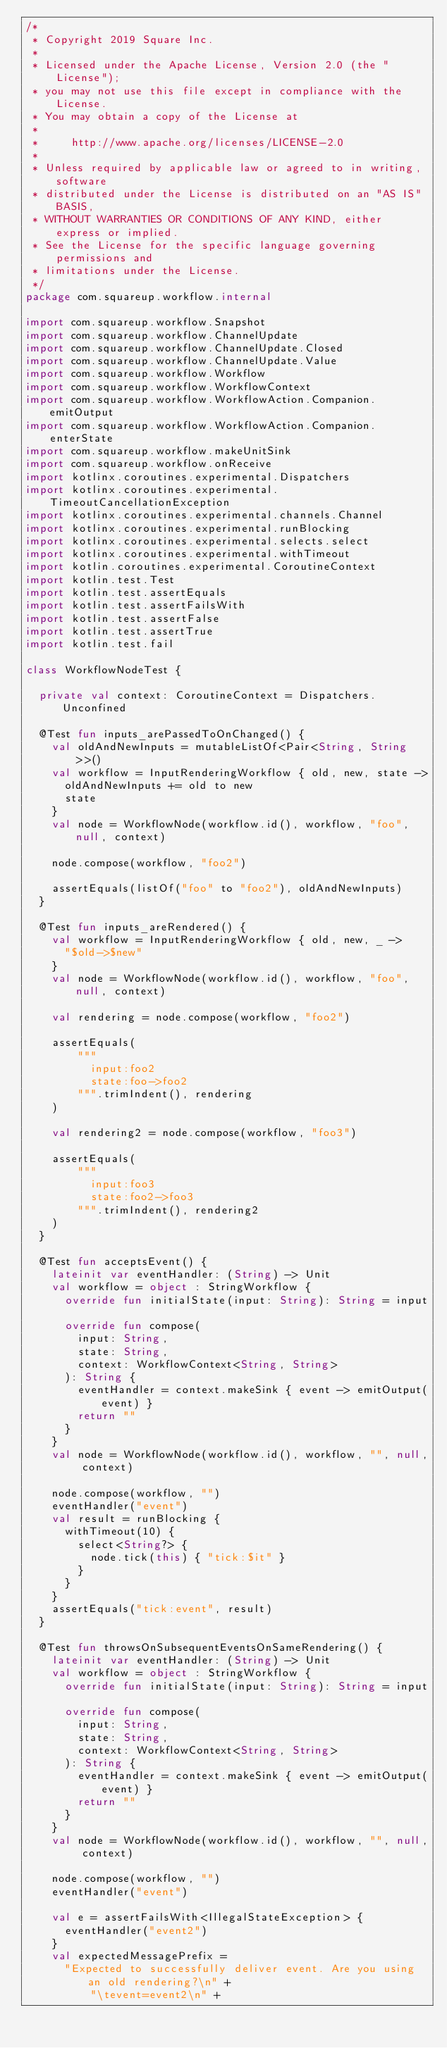Convert code to text. <code><loc_0><loc_0><loc_500><loc_500><_Kotlin_>/*
 * Copyright 2019 Square Inc.
 *
 * Licensed under the Apache License, Version 2.0 (the "License");
 * you may not use this file except in compliance with the License.
 * You may obtain a copy of the License at
 *
 *     http://www.apache.org/licenses/LICENSE-2.0
 *
 * Unless required by applicable law or agreed to in writing, software
 * distributed under the License is distributed on an "AS IS" BASIS,
 * WITHOUT WARRANTIES OR CONDITIONS OF ANY KIND, either express or implied.
 * See the License for the specific language governing permissions and
 * limitations under the License.
 */
package com.squareup.workflow.internal

import com.squareup.workflow.Snapshot
import com.squareup.workflow.ChannelUpdate
import com.squareup.workflow.ChannelUpdate.Closed
import com.squareup.workflow.ChannelUpdate.Value
import com.squareup.workflow.Workflow
import com.squareup.workflow.WorkflowContext
import com.squareup.workflow.WorkflowAction.Companion.emitOutput
import com.squareup.workflow.WorkflowAction.Companion.enterState
import com.squareup.workflow.makeUnitSink
import com.squareup.workflow.onReceive
import kotlinx.coroutines.experimental.Dispatchers
import kotlinx.coroutines.experimental.TimeoutCancellationException
import kotlinx.coroutines.experimental.channels.Channel
import kotlinx.coroutines.experimental.runBlocking
import kotlinx.coroutines.experimental.selects.select
import kotlinx.coroutines.experimental.withTimeout
import kotlin.coroutines.experimental.CoroutineContext
import kotlin.test.Test
import kotlin.test.assertEquals
import kotlin.test.assertFailsWith
import kotlin.test.assertFalse
import kotlin.test.assertTrue
import kotlin.test.fail

class WorkflowNodeTest {

  private val context: CoroutineContext = Dispatchers.Unconfined

  @Test fun inputs_arePassedToOnChanged() {
    val oldAndNewInputs = mutableListOf<Pair<String, String>>()
    val workflow = InputRenderingWorkflow { old, new, state ->
      oldAndNewInputs += old to new
      state
    }
    val node = WorkflowNode(workflow.id(), workflow, "foo", null, context)

    node.compose(workflow, "foo2")

    assertEquals(listOf("foo" to "foo2"), oldAndNewInputs)
  }

  @Test fun inputs_areRendered() {
    val workflow = InputRenderingWorkflow { old, new, _ ->
      "$old->$new"
    }
    val node = WorkflowNode(workflow.id(), workflow, "foo", null, context)

    val rendering = node.compose(workflow, "foo2")

    assertEquals(
        """
          input:foo2
          state:foo->foo2
        """.trimIndent(), rendering
    )

    val rendering2 = node.compose(workflow, "foo3")

    assertEquals(
        """
          input:foo3
          state:foo2->foo3
        """.trimIndent(), rendering2
    )
  }

  @Test fun acceptsEvent() {
    lateinit var eventHandler: (String) -> Unit
    val workflow = object : StringWorkflow {
      override fun initialState(input: String): String = input

      override fun compose(
        input: String,
        state: String,
        context: WorkflowContext<String, String>
      ): String {
        eventHandler = context.makeSink { event -> emitOutput(event) }
        return ""
      }
    }
    val node = WorkflowNode(workflow.id(), workflow, "", null, context)

    node.compose(workflow, "")
    eventHandler("event")
    val result = runBlocking {
      withTimeout(10) {
        select<String?> {
          node.tick(this) { "tick:$it" }
        }
      }
    }
    assertEquals("tick:event", result)
  }

  @Test fun throwsOnSubsequentEventsOnSameRendering() {
    lateinit var eventHandler: (String) -> Unit
    val workflow = object : StringWorkflow {
      override fun initialState(input: String): String = input

      override fun compose(
        input: String,
        state: String,
        context: WorkflowContext<String, String>
      ): String {
        eventHandler = context.makeSink { event -> emitOutput(event) }
        return ""
      }
    }
    val node = WorkflowNode(workflow.id(), workflow, "", null, context)

    node.compose(workflow, "")
    eventHandler("event")

    val e = assertFailsWith<IllegalStateException> {
      eventHandler("event2")
    }
    val expectedMessagePrefix =
      "Expected to successfully deliver event. Are you using an old rendering?\n" +
          "\tevent=event2\n" +</code> 